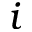<formula> <loc_0><loc_0><loc_500><loc_500>i</formula> 